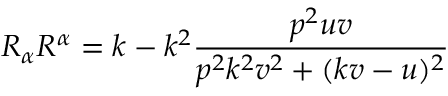Convert formula to latex. <formula><loc_0><loc_0><loc_500><loc_500>R _ { \alpha } R ^ { \alpha } = k - k ^ { 2 } \frac { p ^ { 2 } u v } { p ^ { 2 } k ^ { 2 } v ^ { 2 } + ( k v - u ) ^ { 2 } }</formula> 